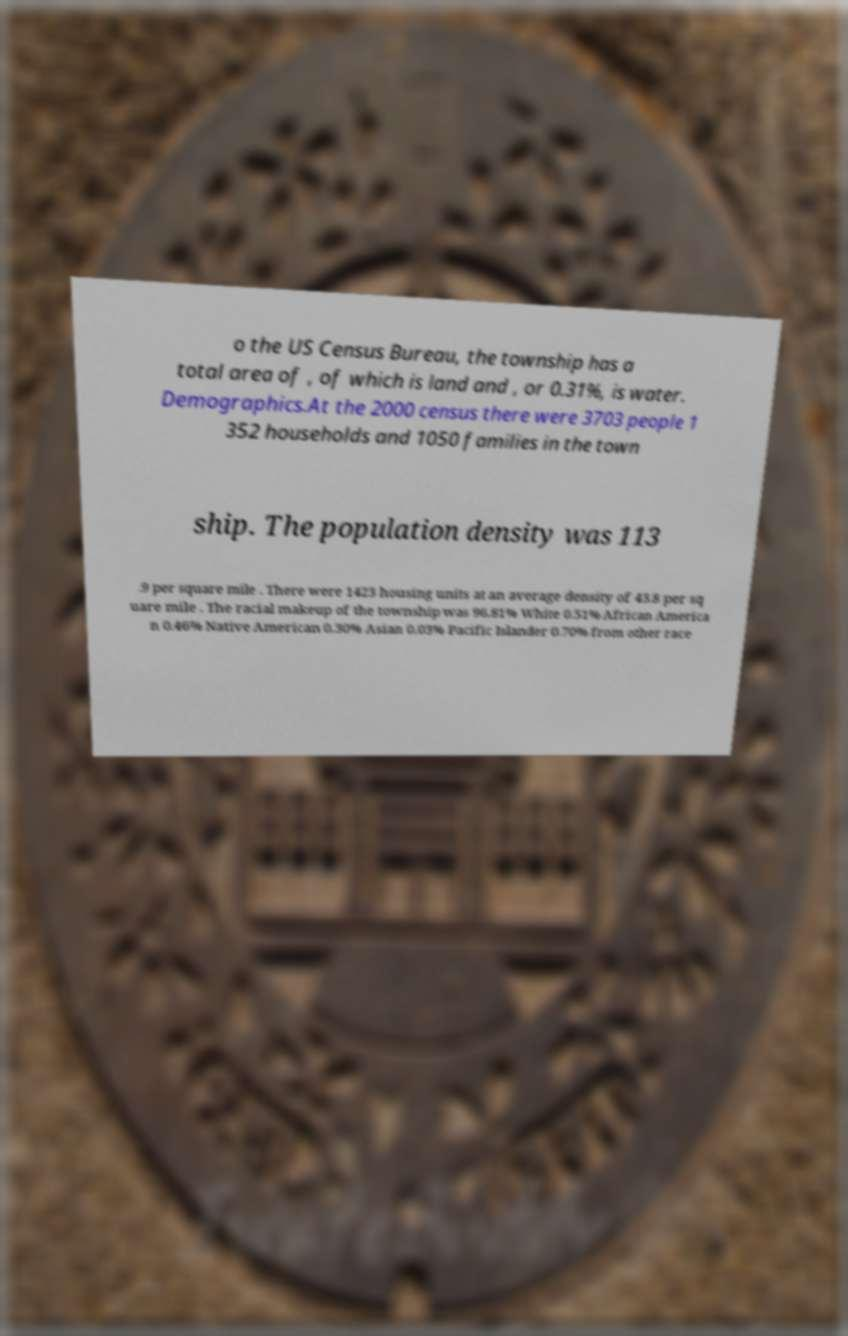Please identify and transcribe the text found in this image. o the US Census Bureau, the township has a total area of , of which is land and , or 0.31%, is water. Demographics.At the 2000 census there were 3703 people 1 352 households and 1050 families in the town ship. The population density was 113 .9 per square mile . There were 1423 housing units at an average density of 43.8 per sq uare mile . The racial makeup of the township was 96.81% White 0.51% African America n 0.46% Native American 0.30% Asian 0.03% Pacific Islander 0.70% from other race 